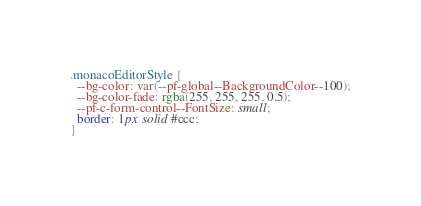<code> <loc_0><loc_0><loc_500><loc_500><_CSS_>.monacoEditorStyle {
  --bg-color: var(--pf-global--BackgroundColor--100);
  --bg-color-fade: rgba(255, 255, 255, 0.5);
  --pf-c-form-control--FontSize: small;
  border: 1px solid #ccc;
}
</code> 